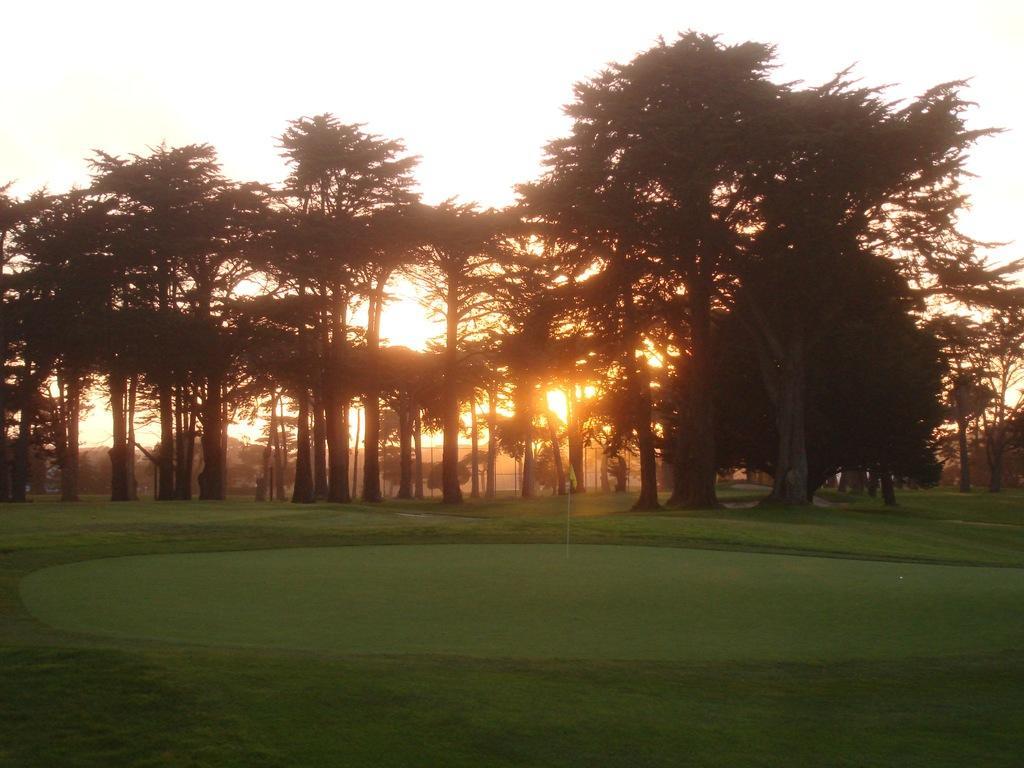How would you summarize this image in a sentence or two? In this image there are trees and grass on the surface. In the background there is a sky. 